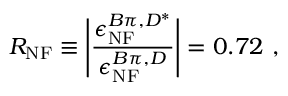<formula> <loc_0><loc_0><loc_500><loc_500>R _ { N F } \equiv \left | \frac { \epsilon _ { N F } ^ { B \pi , D ^ { * } } } { \epsilon _ { N F } ^ { B \pi , D } } \right | = 0 . 7 2 ,</formula> 